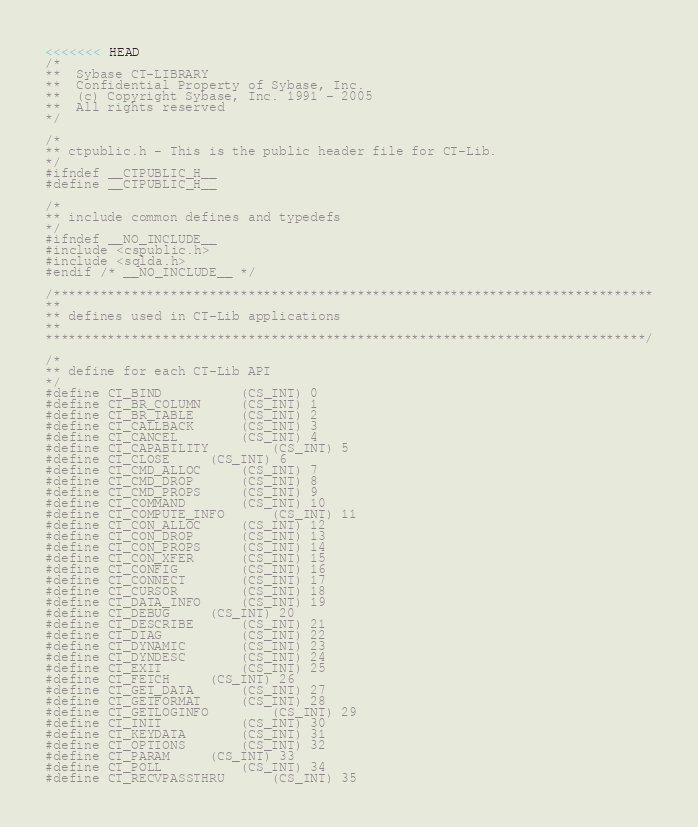<code> <loc_0><loc_0><loc_500><loc_500><_C_><<<<<<< HEAD
/*
**	Sybase CT-LIBRARY
**	Confidential Property of Sybase, Inc.
**	(c) Copyright Sybase, Inc. 1991 - 2005
**	All rights reserved
*/

/*
** ctpublic.h - This is the public header file for CT-Lib.
*/
#ifndef __CTPUBLIC_H__
#define __CTPUBLIC_H__

/*
** include common defines and typedefs
*/
#ifndef __NO_INCLUDE__
#include <cspublic.h>
#include <sqlda.h>
#endif /* __NO_INCLUDE__ */

/*****************************************************************************
**
** defines used in CT-Lib applications
**
*****************************************************************************/

/*
** define for each CT-Lib API
*/
#define CT_BIND			(CS_INT) 0
#define CT_BR_COLUMN		(CS_INT) 1
#define CT_BR_TABLE		(CS_INT) 2
#define CT_CALLBACK		(CS_INT) 3
#define CT_CANCEL		(CS_INT) 4
#define CT_CAPABILITY		(CS_INT) 5
#define CT_CLOSE		(CS_INT) 6
#define CT_CMD_ALLOC		(CS_INT) 7
#define CT_CMD_DROP		(CS_INT) 8
#define CT_CMD_PROPS		(CS_INT) 9
#define CT_COMMAND		(CS_INT) 10
#define CT_COMPUTE_INFO		(CS_INT) 11
#define CT_CON_ALLOC		(CS_INT) 12
#define CT_CON_DROP		(CS_INT) 13
#define CT_CON_PROPS		(CS_INT) 14
#define CT_CON_XFER		(CS_INT) 15
#define CT_CONFIG		(CS_INT) 16
#define CT_CONNECT		(CS_INT) 17
#define CT_CURSOR		(CS_INT) 18
#define CT_DATA_INFO		(CS_INT) 19
#define CT_DEBUG		(CS_INT) 20
#define CT_DESCRIBE		(CS_INT) 21
#define CT_DIAG			(CS_INT) 22
#define CT_DYNAMIC		(CS_INT) 23
#define CT_DYNDESC		(CS_INT) 24
#define CT_EXIT			(CS_INT) 25
#define CT_FETCH		(CS_INT) 26
#define CT_GET_DATA		(CS_INT) 27
#define CT_GETFORMAT		(CS_INT) 28
#define CT_GETLOGINFO		(CS_INT) 29
#define CT_INIT			(CS_INT) 30
#define CT_KEYDATA		(CS_INT) 31
#define CT_OPTIONS		(CS_INT) 32
#define CT_PARAM		(CS_INT) 33
#define CT_POLL			(CS_INT) 34
#define CT_RECVPASSTHRU		(CS_INT) 35</code> 